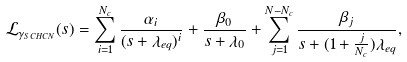<formula> <loc_0><loc_0><loc_500><loc_500>\mathcal { L } _ { \gamma _ { S C H C N } } ( s ) & = \sum _ { i = 1 } ^ { N _ { c } } \frac { \alpha _ { i } } { ( s + \lambda _ { e q } ) ^ { i } } + \frac { \beta _ { 0 } } { s + \lambda _ { 0 } } + \sum _ { j = 1 } ^ { N - N _ { c } } \frac { \beta _ { j } } { s + ( 1 + \frac { j } { N _ { c } } ) \lambda _ { e q } } , \\</formula> 